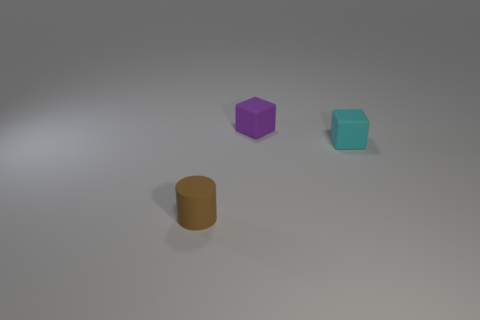Add 1 small purple matte blocks. How many objects exist? 4 Subtract all purple blocks. How many blocks are left? 1 Subtract all cylinders. How many objects are left? 2 Subtract 0 cyan spheres. How many objects are left? 3 Subtract all red cylinders. Subtract all red blocks. How many cylinders are left? 1 Subtract all brown cylinders. How many cyan blocks are left? 1 Subtract all small brown objects. Subtract all tiny cyan objects. How many objects are left? 1 Add 3 tiny purple rubber things. How many tiny purple rubber things are left? 4 Add 3 tiny cyan cubes. How many tiny cyan cubes exist? 4 